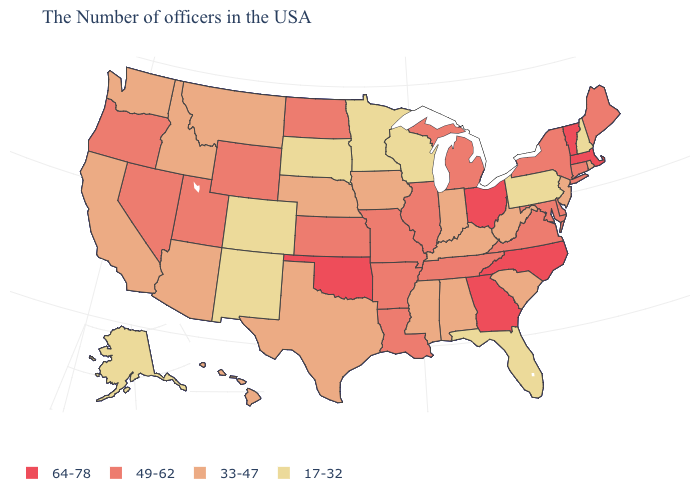Name the states that have a value in the range 49-62?
Give a very brief answer. Maine, Connecticut, New York, Delaware, Maryland, Virginia, Michigan, Tennessee, Illinois, Louisiana, Missouri, Arkansas, Kansas, North Dakota, Wyoming, Utah, Nevada, Oregon. How many symbols are there in the legend?
Answer briefly. 4. What is the lowest value in states that border Wisconsin?
Quick response, please. 17-32. What is the value of Idaho?
Concise answer only. 33-47. How many symbols are there in the legend?
Write a very short answer. 4. What is the lowest value in states that border Arkansas?
Keep it brief. 33-47. What is the value of Vermont?
Write a very short answer. 64-78. Name the states that have a value in the range 33-47?
Keep it brief. Rhode Island, New Jersey, South Carolina, West Virginia, Kentucky, Indiana, Alabama, Mississippi, Iowa, Nebraska, Texas, Montana, Arizona, Idaho, California, Washington, Hawaii. Does the first symbol in the legend represent the smallest category?
Keep it brief. No. What is the lowest value in states that border Missouri?
Short answer required. 33-47. Does North Carolina have the highest value in the USA?
Quick response, please. Yes. Name the states that have a value in the range 64-78?
Answer briefly. Massachusetts, Vermont, North Carolina, Ohio, Georgia, Oklahoma. What is the value of Arizona?
Keep it brief. 33-47. What is the value of Indiana?
Keep it brief. 33-47. What is the lowest value in the South?
Short answer required. 17-32. 